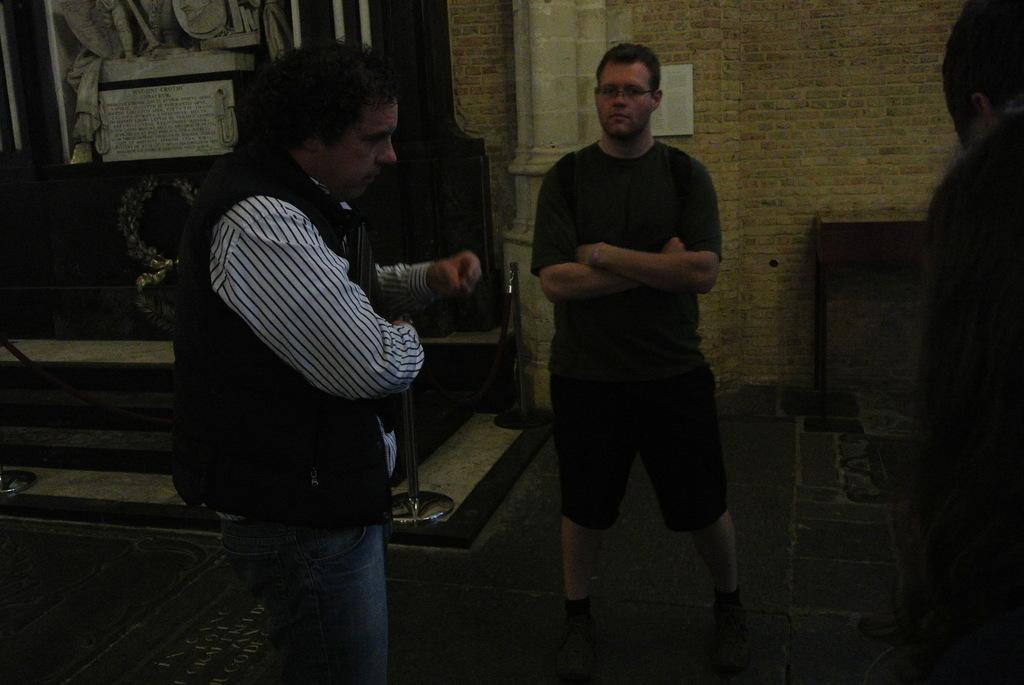What is the position of the first man in the image? The first man is standing on the left side of the image. What is the first man wearing in the image? The first man is wearing a shirt and trousers. How many men are visible in the image? There are two men visible in the image. What is the second man wearing in the image? The second man is wearing a t-shirt and shorts. What can be seen behind the second man in the image? There is a wall visible behind the second man. What type of flock can be seen flying over the men in the image? There is no flock of birds or animals visible in the image. What is the rail used for in the image? There is no rail present in the image. 